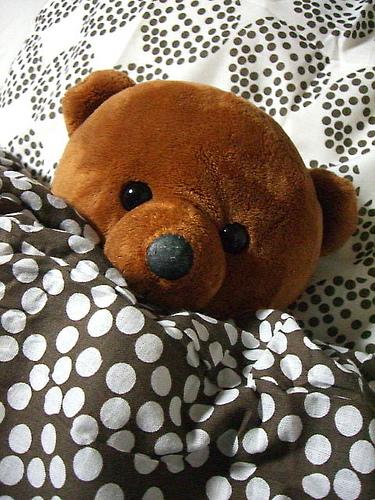What is covering the bear?
Short answer required. Blanket. Which part of the bedding has the larger dots?
Write a very short answer. Comforter. Does the teddy bear have black eyes?
Be succinct. Yes. 